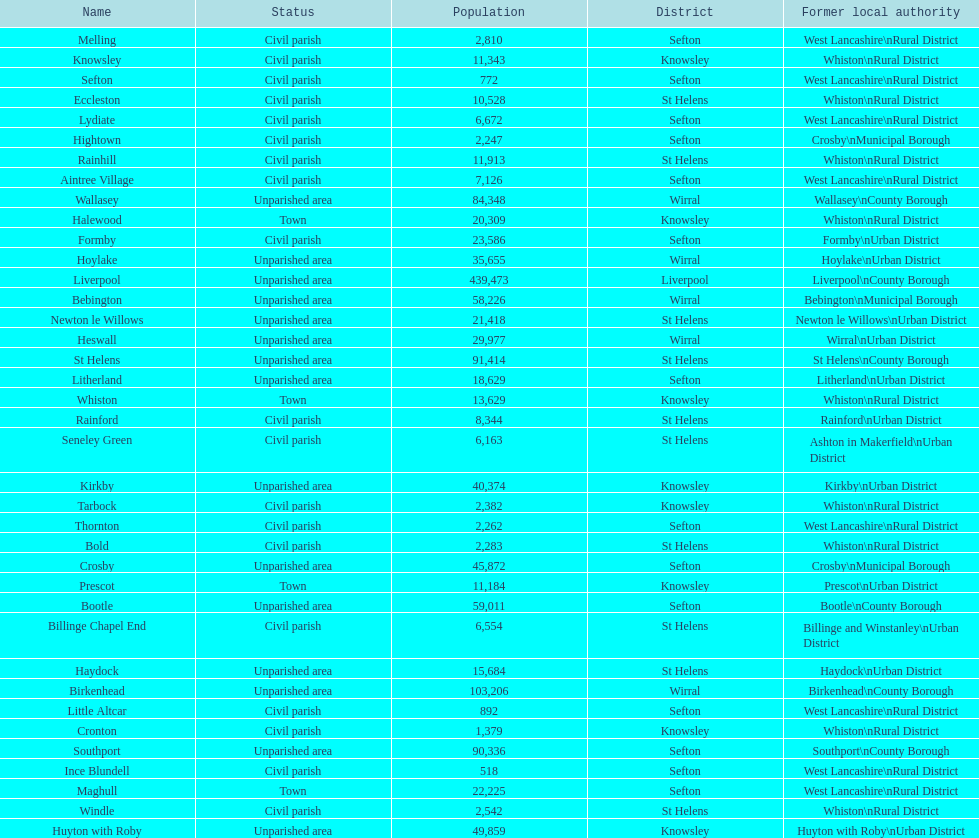What is the largest area in terms of population? Liverpool. 